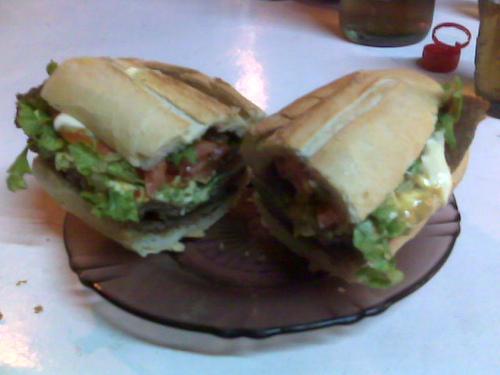Is there a glass on the table?
Answer briefly. Yes. What is the sandwich made of?
Write a very short answer. Avocado. Is the sandwich on a cutting board?
Give a very brief answer. No. 